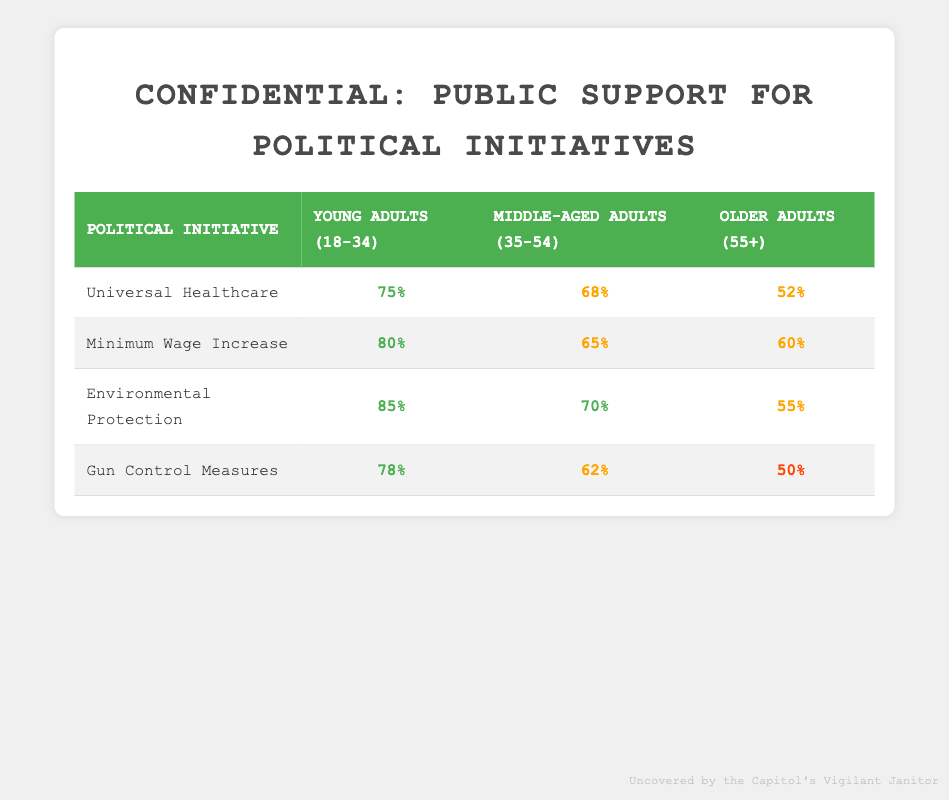What is the support percentage for Environmental Protection among Young Adults (18-34)? The support percentage for Environmental Protection can be found directly in the table, where the row for Environmental Protection and the column for Young Adults (18-34) intersect. The value is 85%.
Answer: 85% What demographic group shows the highest support for Minimum Wage Increase? The table reflects that among the demographic groups, Young Adults (18-34) have the highest support for Minimum Wage Increase at 80%.
Answer: Young Adults (18-34) What is the difference in support between Middle-aged Adults (35-54) for Universal Healthcare and Gun Control Measures? From the table, the support for Middle-aged Adults (35-54) is 68% for Universal Healthcare and 62% for Gun Control Measures. The difference is 68% - 62% = 6%.
Answer: 6% Is the support for Gun Control Measures among Older Adults (55+) less than 60%? The table indicates that the support for Gun Control Measures among Older Adults (55+) is 50%, which is indeed less than 60%.
Answer: Yes What is the average support percentage for Universal Healthcare across all demographic groups? To calculate the average support for Universal Healthcare, we take the values for each demographic group: 75% (Young Adults) + 68% (Middle-aged Adults) + 52% (Older Adults) = 195%. Then we divide by 3 (the number of groups), which gives us an average of 195% / 3 = 65%.
Answer: 65% What demographic group has the lowest overall support for Environmental Protection? Looking at the table, the support for Environmental Protection among Older Adults (55+) is the lowest at 55%. Thus, this demographic group has the lowest overall support for this initiative.
Answer: Older Adults (55+) How much more support does Young Adults (18-34) have for Environmental Protection compared to Older Adults (55+)? The support for Environmental Protection is 85% for Young Adults (18-34) and 55% for Older Adults (55+). The difference is 85% - 55% = 30%.
Answer: 30% Which political initiative has the highest support among Middle-aged Adults (35-54)? From the table, we can see that among Middle-aged Adults (35-54), Environmental Protection has the highest support at 70%.
Answer: Environmental Protection 